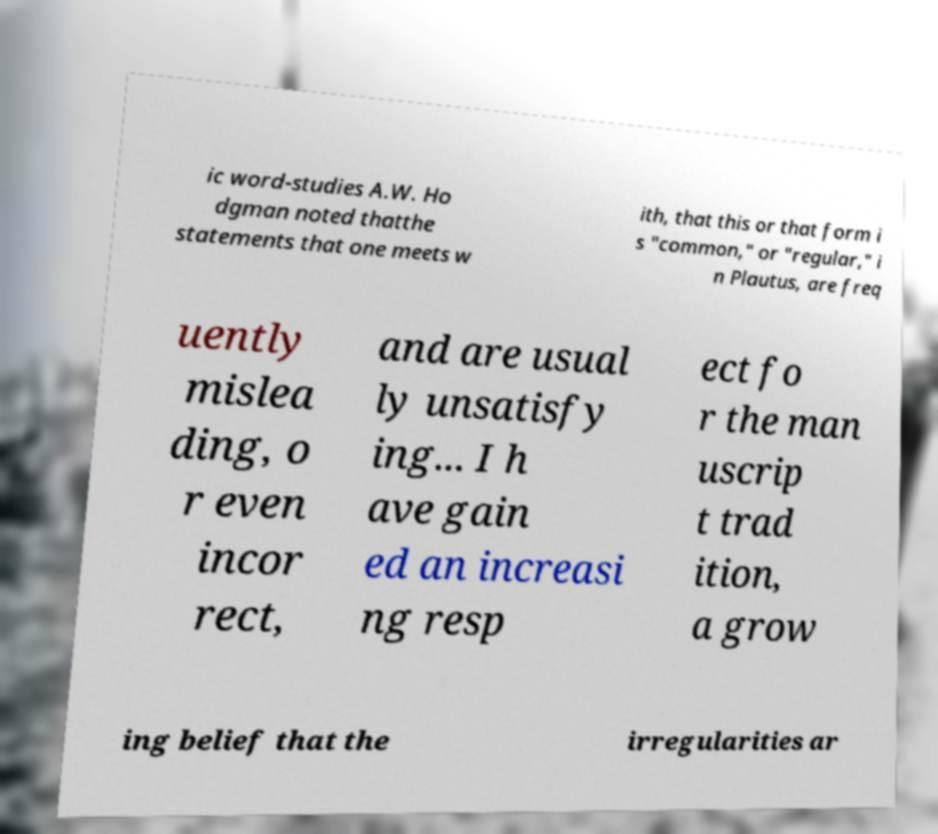Please identify and transcribe the text found in this image. ic word-studies A.W. Ho dgman noted thatthe statements that one meets w ith, that this or that form i s "common," or "regular," i n Plautus, are freq uently mislea ding, o r even incor rect, and are usual ly unsatisfy ing... I h ave gain ed an increasi ng resp ect fo r the man uscrip t trad ition, a grow ing belief that the irregularities ar 